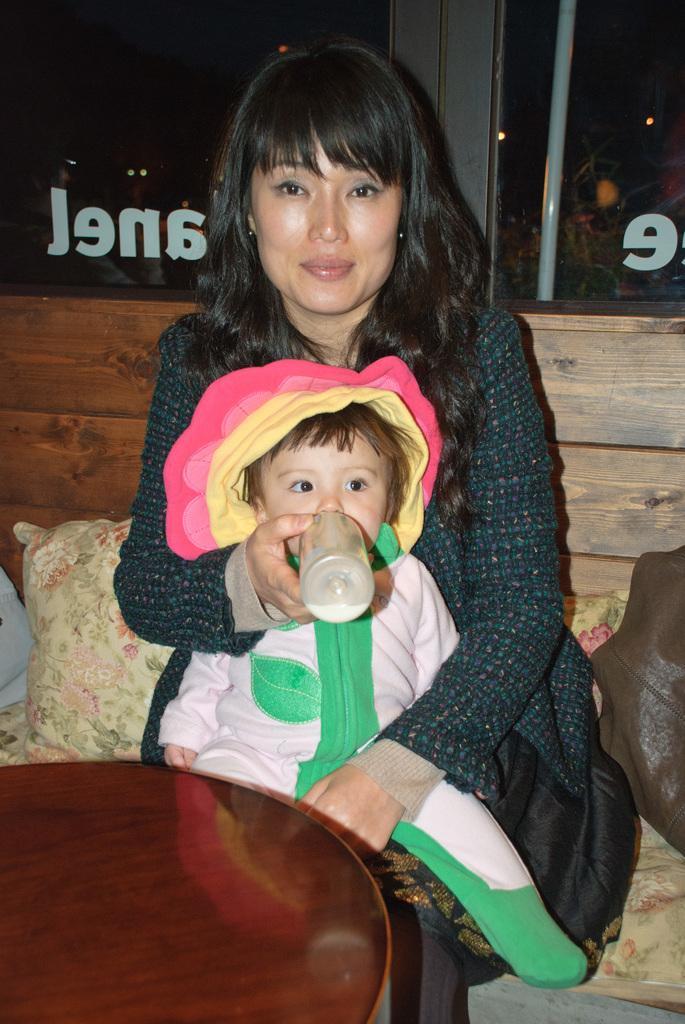In one or two sentences, can you explain what this image depicts? In this picture we can see woman sitting and holding milk bottle in her hand and smiling and on her we can see a baby and in front of her table, pillows, wall. 